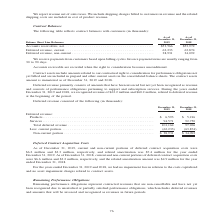According to A10 Networks's financial document, What does deferred revenue refer to? Deferred revenue primarily consists of amounts that have been invoiced but not yet been recognized as revenue and consists of performance obligations pertaining to support and subscription services. The document states: "Deferred revenue primarily consists of amounts that have been invoiced but not yet been recognized as revenue and consists of performance obligations ..." Also, What is the revenue recognized related to deferred revenue in 2019? According to the financial document, $60.2 million. The relevant text states: "d 2018, we recognized revenue of $63.2 million and $60.2 million, related to deferred revenue at the beginning of the period...." Also, What is the revenue recognized related to deferred revenue in 2018? According to the financial document, $63.2 million. The relevant text states: "cember 31, 2019 and 2018, we recognized revenue of $63.2 million and $60.2 million, related to deferred revenue at the beginning of the period...." Also, can you calculate: What proportion of the revenue recognized related to deferred revenue is the non-current portion of the deferred revenue in 2019? To answer this question, I need to perform calculations using the financial data. The calculation is: (63.2 million - 38,931 thousand)/38,931 thousand , which equals 62.34 (percentage). This is based on the information: ". . 62,233 63,874 Deferred revenue, non-current . 38,931 34,092 mber 31, 2019 and 2018, we recognized revenue of $63.2 million and $60.2 million, related to deferred revenue at the beginning of the pe..." The key data points involved are: 38,931, 63.2. Also, can you calculate: What is the percentage change in total deferred revenue 2018 and 2019? To answer this question, I need to perform calculations using the financial data. The calculation is: (101,164 - 97,966)/97,966 , which equals 3.26 (percentage). This is based on the information: "Total deferred revenue . 101,164 97,966 Less: current portion. . (62,233) (63,874) Total deferred revenue . 101,164 97,966 Less: current portion. . (62,233) (63,874)..." The key data points involved are: 101,164, 97,966. Also, can you calculate: What is the total non-current portion of the deferred revenue between 2018 and 2019? Based on the calculation: 101,164+97,966, the result is 199130 (in thousands). This is based on the information: "Total deferred revenue . 101,164 97,966 Less: current portion. . (62,233) (63,874) Total deferred revenue . 101,164 97,966 Less: current portion. . (62,233) (63,874)..." The key data points involved are: 101,164, 97,966. 